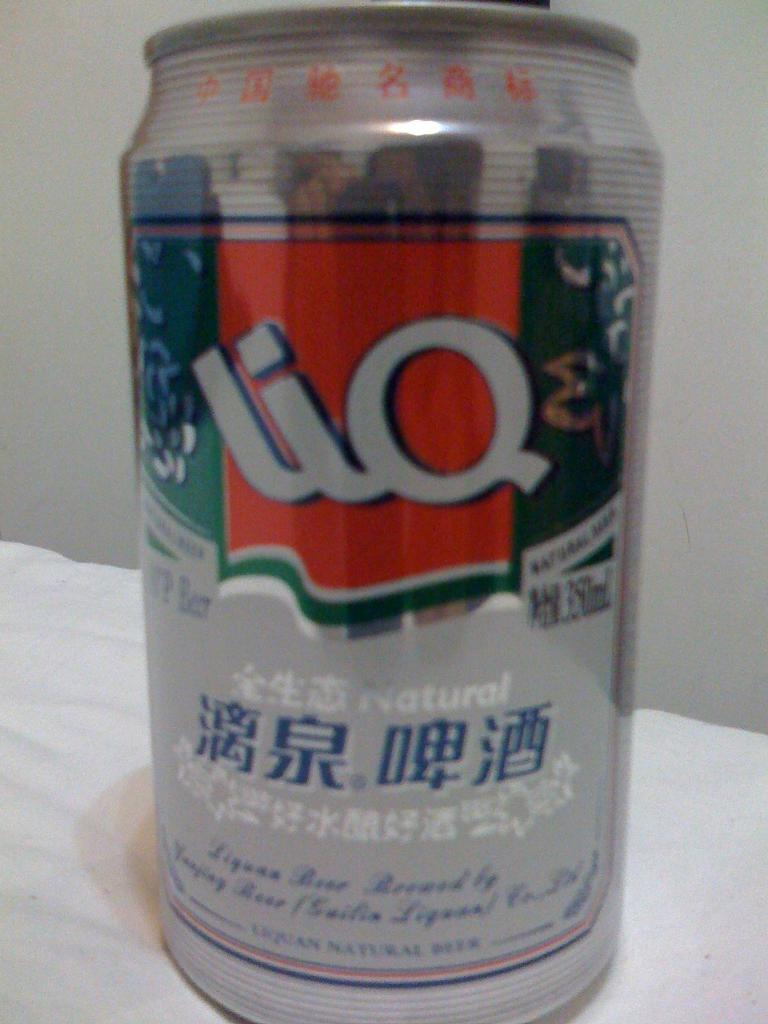What is this drink?
Your answer should be compact. Liq. 